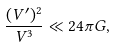Convert formula to latex. <formula><loc_0><loc_0><loc_500><loc_500>\frac { ( V ^ { \prime } ) ^ { 2 } } { V ^ { 3 } } \ll 2 4 \pi G ,</formula> 